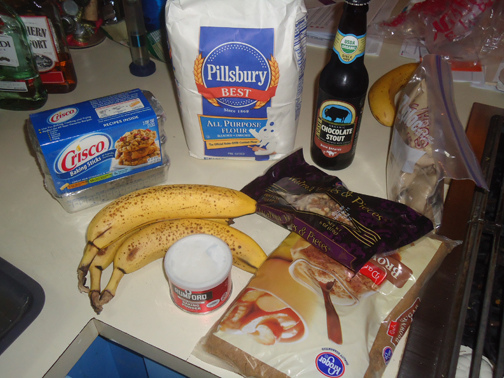<image>What does it say on the glass? I don't know what it says on the glass. It can be 'chocolate stout' or 'chocolate syrup'. What does it say on the glass? I am not sure what it says on the glass. It can be seen 'chocolate stout', 'chocolate syrup' or 'chocolate swirl'. 